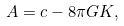<formula> <loc_0><loc_0><loc_500><loc_500>A = c - 8 \pi G K ,</formula> 